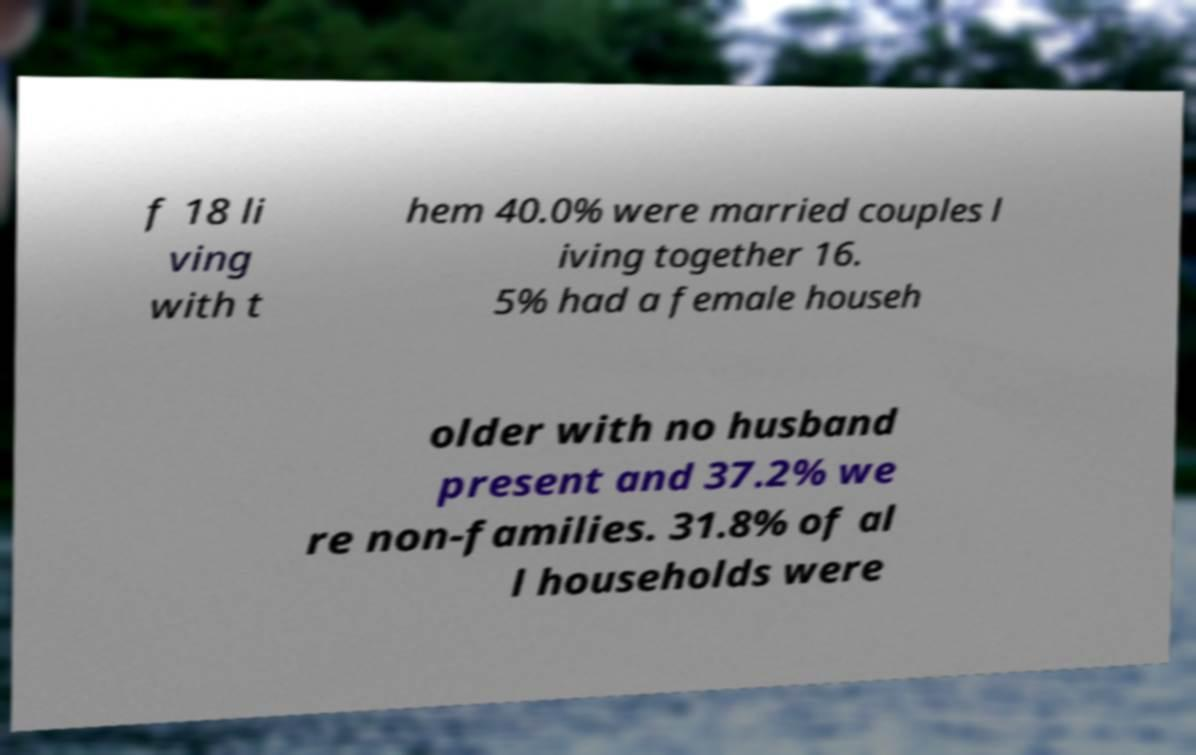Can you read and provide the text displayed in the image?This photo seems to have some interesting text. Can you extract and type it out for me? f 18 li ving with t hem 40.0% were married couples l iving together 16. 5% had a female househ older with no husband present and 37.2% we re non-families. 31.8% of al l households were 